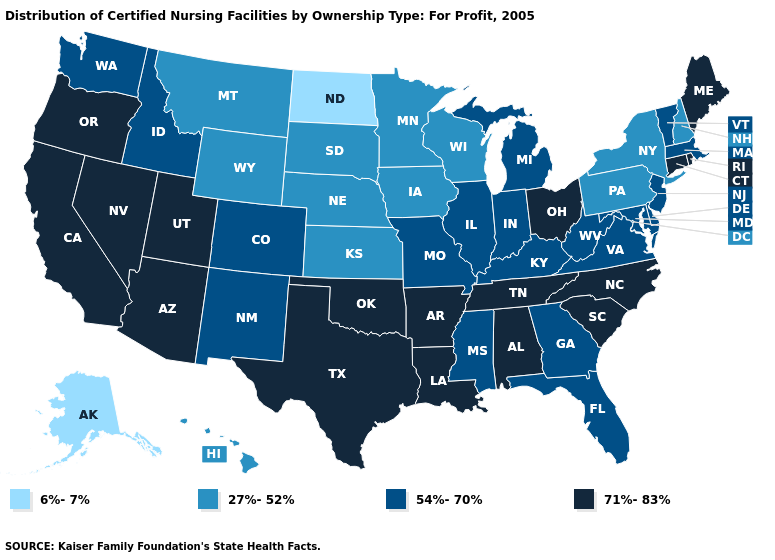How many symbols are there in the legend?
Write a very short answer. 4. Does Florida have a lower value than New Hampshire?
Answer briefly. No. Which states hav the highest value in the West?
Quick response, please. Arizona, California, Nevada, Oregon, Utah. What is the value of Maryland?
Write a very short answer. 54%-70%. Does Oregon have the highest value in the USA?
Concise answer only. Yes. What is the lowest value in states that border Wisconsin?
Short answer required. 27%-52%. Name the states that have a value in the range 71%-83%?
Quick response, please. Alabama, Arizona, Arkansas, California, Connecticut, Louisiana, Maine, Nevada, North Carolina, Ohio, Oklahoma, Oregon, Rhode Island, South Carolina, Tennessee, Texas, Utah. Name the states that have a value in the range 54%-70%?
Answer briefly. Colorado, Delaware, Florida, Georgia, Idaho, Illinois, Indiana, Kentucky, Maryland, Massachusetts, Michigan, Mississippi, Missouri, New Jersey, New Mexico, Vermont, Virginia, Washington, West Virginia. What is the lowest value in states that border Kansas?
Keep it brief. 27%-52%. Which states have the lowest value in the Northeast?
Quick response, please. New Hampshire, New York, Pennsylvania. Does Oklahoma have the lowest value in the South?
Answer briefly. No. What is the highest value in the Northeast ?
Concise answer only. 71%-83%. Which states have the highest value in the USA?
Short answer required. Alabama, Arizona, Arkansas, California, Connecticut, Louisiana, Maine, Nevada, North Carolina, Ohio, Oklahoma, Oregon, Rhode Island, South Carolina, Tennessee, Texas, Utah. Name the states that have a value in the range 6%-7%?
Write a very short answer. Alaska, North Dakota. 